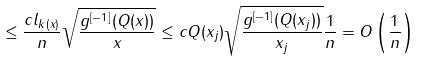<formula> <loc_0><loc_0><loc_500><loc_500>\leq \frac { c l _ { k ( x ) } } { n } \sqrt { \frac { g ^ { [ - 1 ] } ( Q ( x ) ) } { x } } \leq c Q ( x _ { j } ) \sqrt { \frac { g ^ { [ - 1 ] } ( Q ( x _ { j } ) ) } { x _ { j } } } \frac { 1 } { n } = O \left ( \frac { 1 } { n } \right )</formula> 